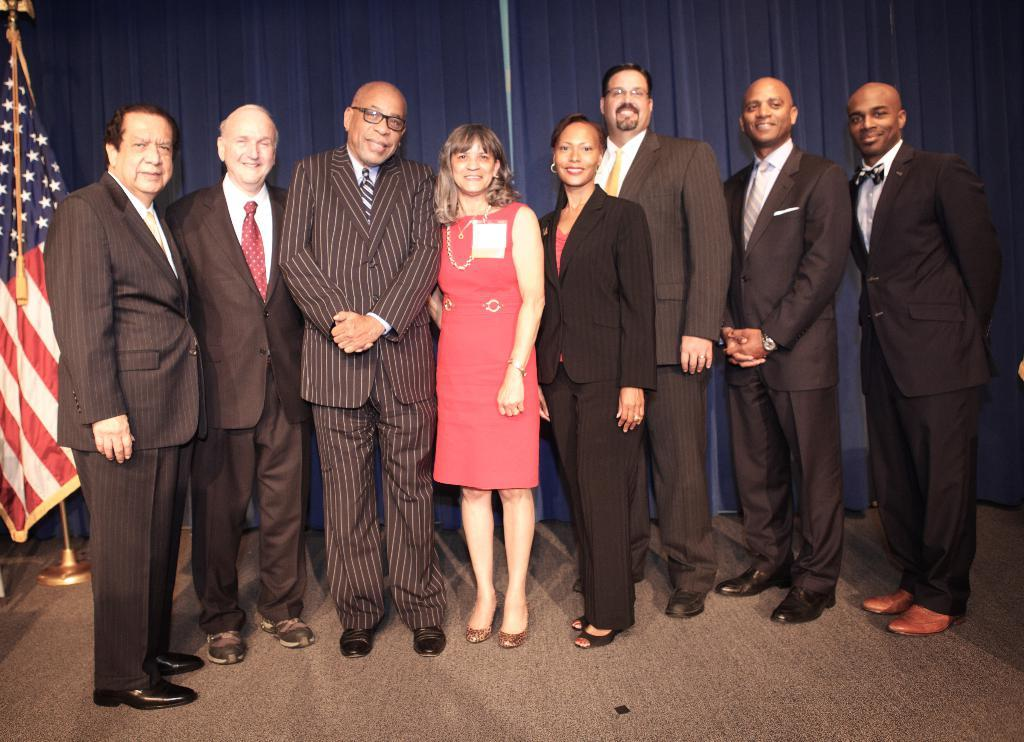What can be seen in the image? There are people standing in the image. Is there any other object or symbol present in the image? Yes, there is a flag placed in the image. Can you see any mountains in the image? No, there are no mountains visible in the image. Is there a flame present in the image? No, there is no flame present in the image. 